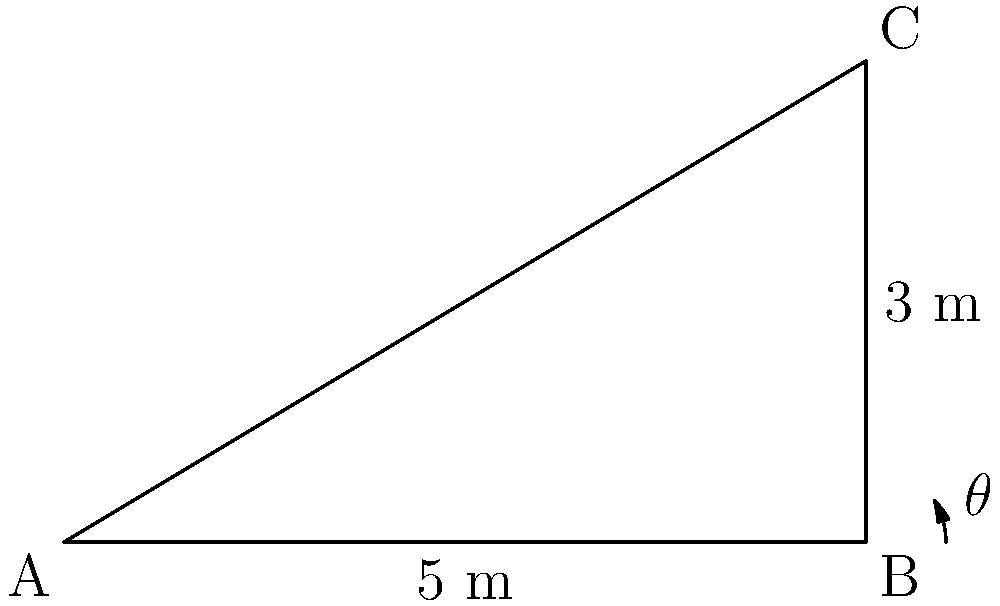As you prepare to paint a rolling hillside landscape, you want to accurately represent the angle of inclination. You measure a section of the hill and find that it rises 3 meters over a horizontal distance of 5 meters. What is the angle of inclination ($\theta$) of this hillside in degrees? To find the angle of inclination, we can use the trigonometric function tangent. Here's how to solve it step-by-step:

1) In a right triangle, tangent of an angle is the ratio of the opposite side to the adjacent side.

2) In this case:
   - The rise (opposite side) is 3 meters
   - The horizontal distance (adjacent side) is 5 meters

3) So, we can write:
   $$\tan(\theta) = \frac{\text{opposite}}{\text{adjacent}} = \frac{3}{5}$$

4) To find $\theta$, we need to use the inverse tangent (arctan or $\tan^{-1}$):
   $$\theta = \tan^{-1}\left(\frac{3}{5}\right)$$

5) Using a calculator or computer:
   $$\theta \approx 30.96^\circ$$

6) Rounding to the nearest degree:
   $$\theta \approx 31^\circ$$

This angle represents the inclination of the hillside you're planning to paint.
Answer: $31^\circ$ 